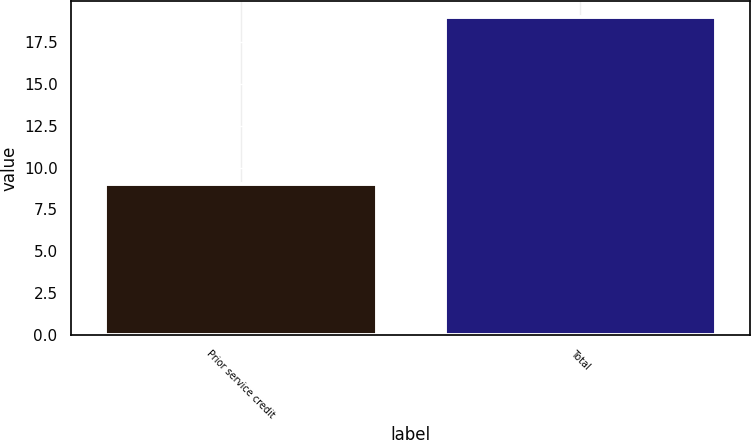Convert chart to OTSL. <chart><loc_0><loc_0><loc_500><loc_500><bar_chart><fcel>Prior service credit<fcel>Total<nl><fcel>9<fcel>19<nl></chart> 